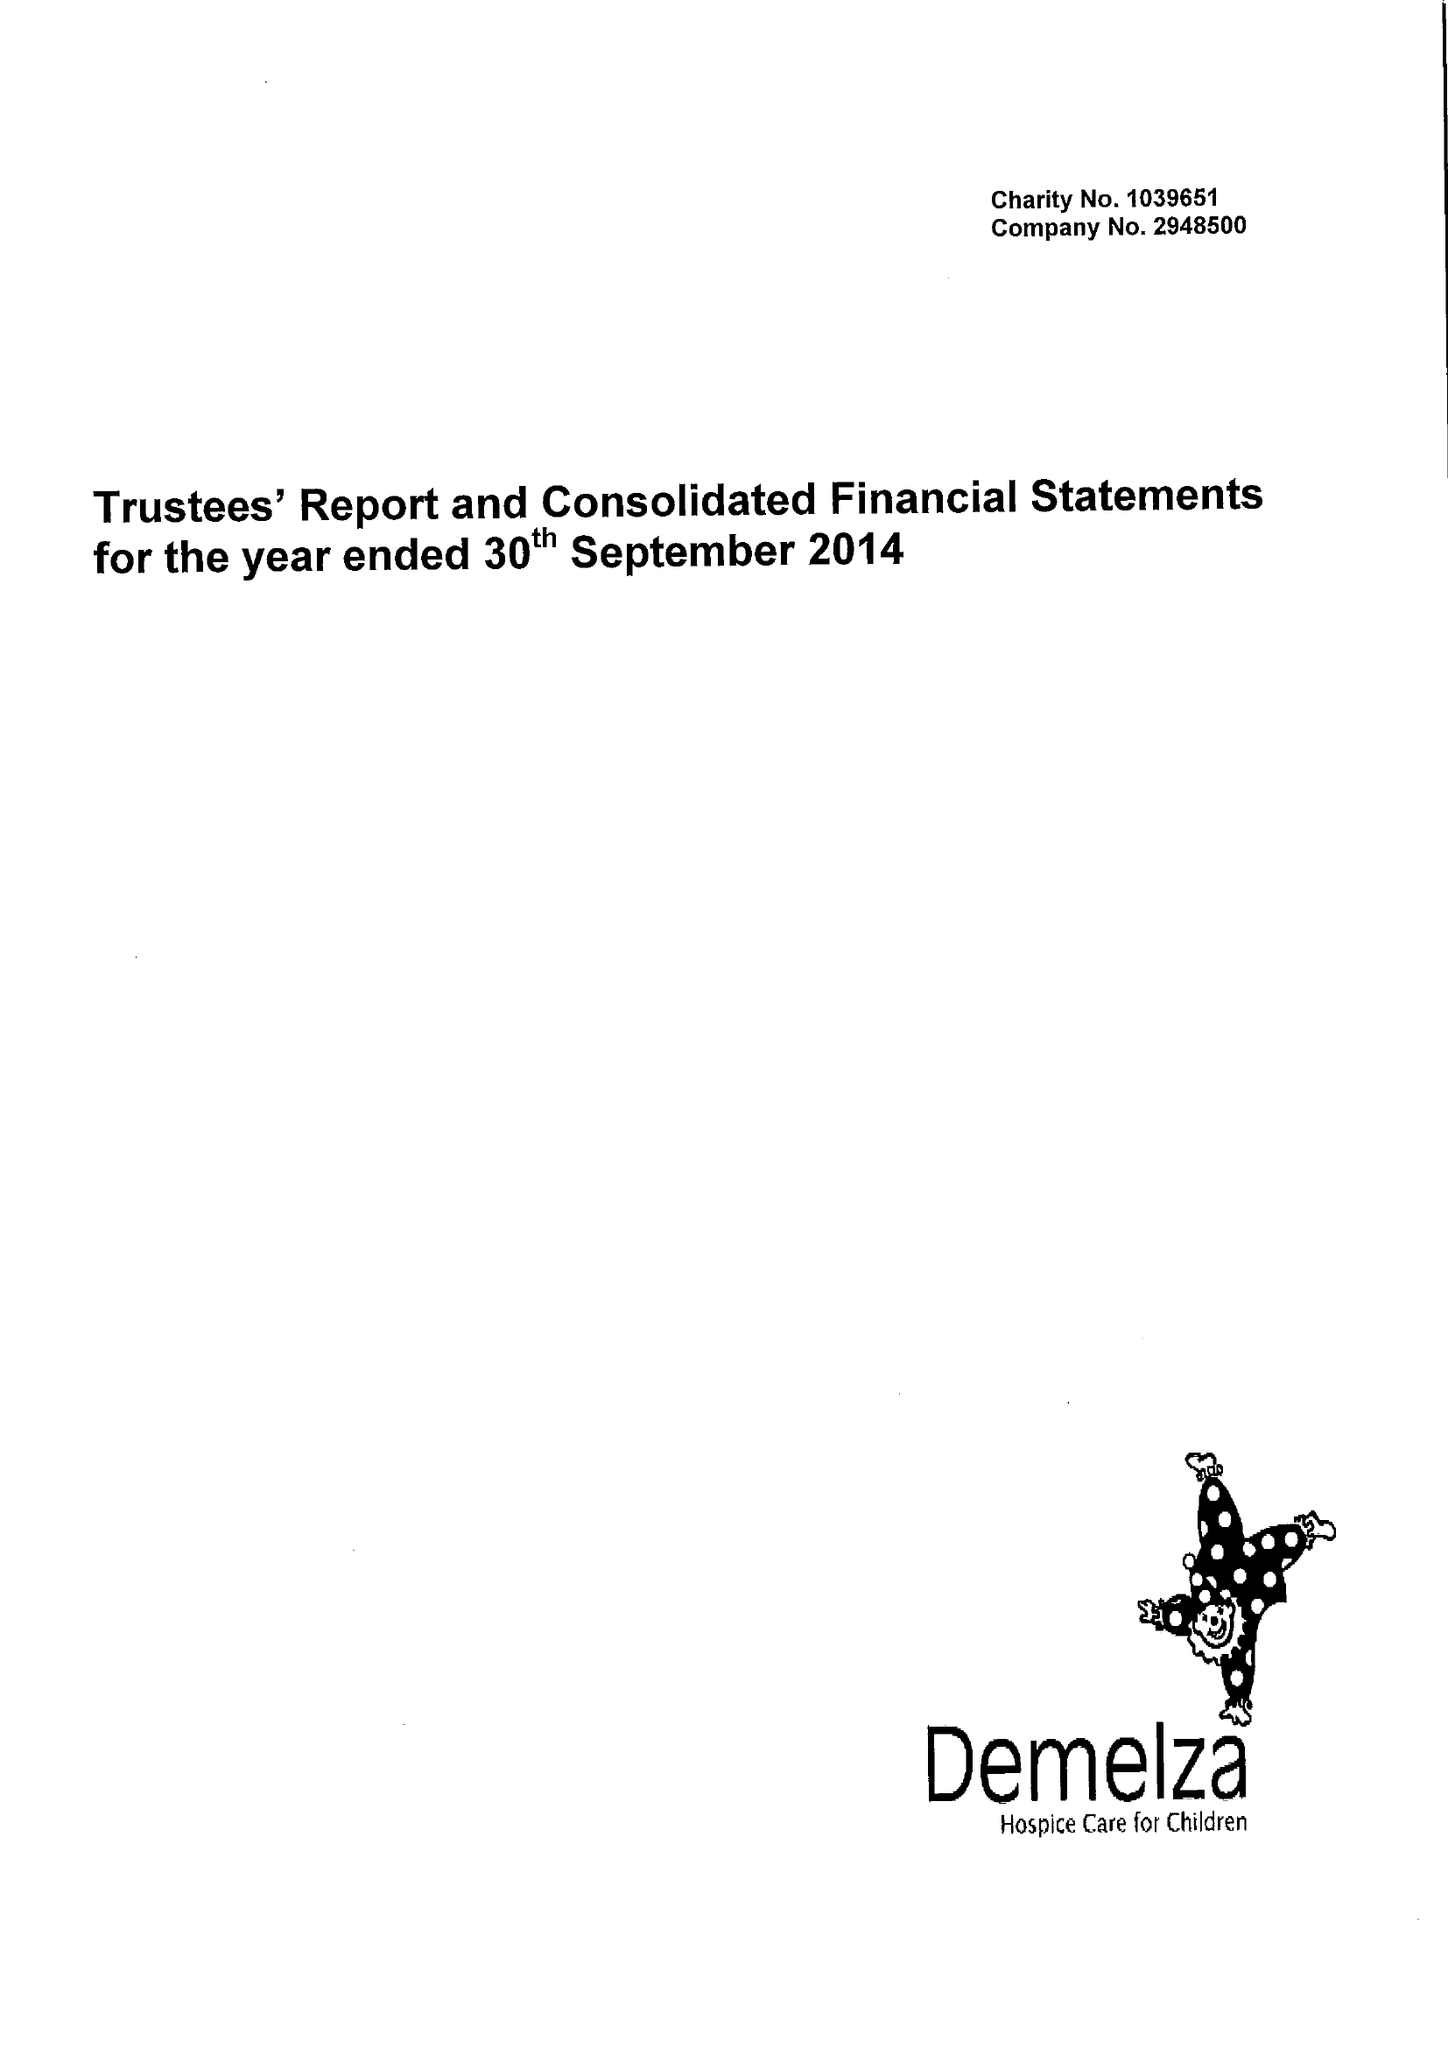What is the value for the address__street_line?
Answer the question using a single word or phrase. ROOK LANE 